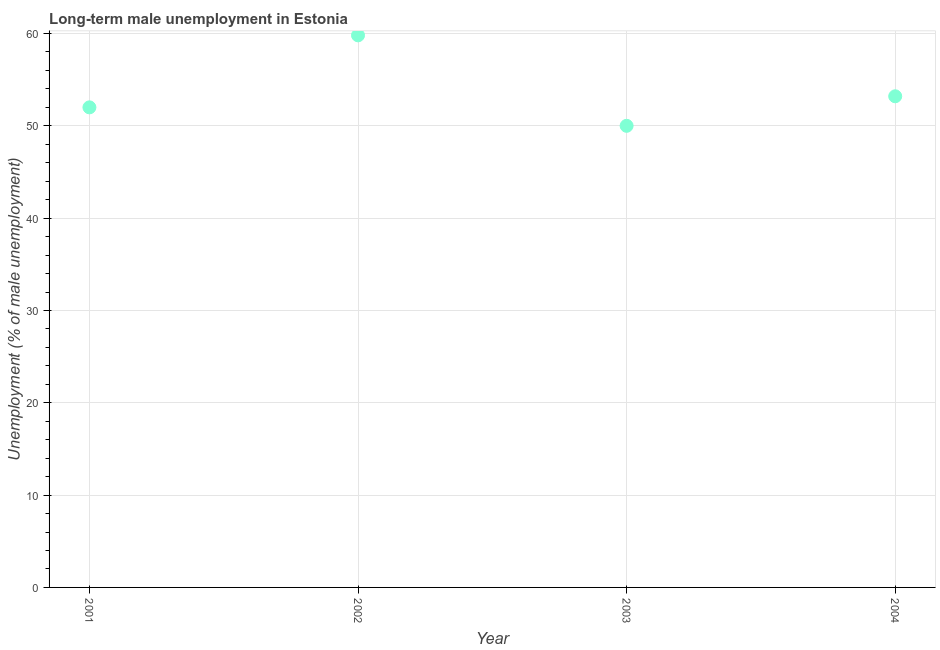What is the long-term male unemployment in 2002?
Make the answer very short. 59.8. Across all years, what is the maximum long-term male unemployment?
Offer a terse response. 59.8. What is the sum of the long-term male unemployment?
Make the answer very short. 215. What is the difference between the long-term male unemployment in 2003 and 2004?
Offer a terse response. -3.2. What is the average long-term male unemployment per year?
Make the answer very short. 53.75. What is the median long-term male unemployment?
Provide a succinct answer. 52.6. Do a majority of the years between 2004 and 2003 (inclusive) have long-term male unemployment greater than 34 %?
Ensure brevity in your answer.  No. What is the ratio of the long-term male unemployment in 2001 to that in 2002?
Provide a short and direct response. 0.87. Is the long-term male unemployment in 2002 less than that in 2003?
Provide a succinct answer. No. Is the difference between the long-term male unemployment in 2001 and 2004 greater than the difference between any two years?
Ensure brevity in your answer.  No. What is the difference between the highest and the second highest long-term male unemployment?
Give a very brief answer. 6.6. What is the difference between the highest and the lowest long-term male unemployment?
Your answer should be very brief. 9.8. In how many years, is the long-term male unemployment greater than the average long-term male unemployment taken over all years?
Your answer should be very brief. 1. How many dotlines are there?
Provide a short and direct response. 1. How many years are there in the graph?
Offer a very short reply. 4. What is the difference between two consecutive major ticks on the Y-axis?
Your response must be concise. 10. Does the graph contain grids?
Your response must be concise. Yes. What is the title of the graph?
Your answer should be very brief. Long-term male unemployment in Estonia. What is the label or title of the Y-axis?
Provide a succinct answer. Unemployment (% of male unemployment). What is the Unemployment (% of male unemployment) in 2002?
Provide a succinct answer. 59.8. What is the Unemployment (% of male unemployment) in 2004?
Your answer should be very brief. 53.2. What is the difference between the Unemployment (% of male unemployment) in 2001 and 2002?
Offer a terse response. -7.8. What is the difference between the Unemployment (% of male unemployment) in 2001 and 2003?
Provide a succinct answer. 2. What is the difference between the Unemployment (% of male unemployment) in 2001 and 2004?
Keep it short and to the point. -1.2. What is the difference between the Unemployment (% of male unemployment) in 2002 and 2003?
Ensure brevity in your answer.  9.8. What is the difference between the Unemployment (% of male unemployment) in 2003 and 2004?
Your answer should be compact. -3.2. What is the ratio of the Unemployment (% of male unemployment) in 2001 to that in 2002?
Your answer should be very brief. 0.87. What is the ratio of the Unemployment (% of male unemployment) in 2001 to that in 2004?
Your answer should be very brief. 0.98. What is the ratio of the Unemployment (% of male unemployment) in 2002 to that in 2003?
Make the answer very short. 1.2. What is the ratio of the Unemployment (% of male unemployment) in 2002 to that in 2004?
Offer a very short reply. 1.12. What is the ratio of the Unemployment (% of male unemployment) in 2003 to that in 2004?
Your response must be concise. 0.94. 